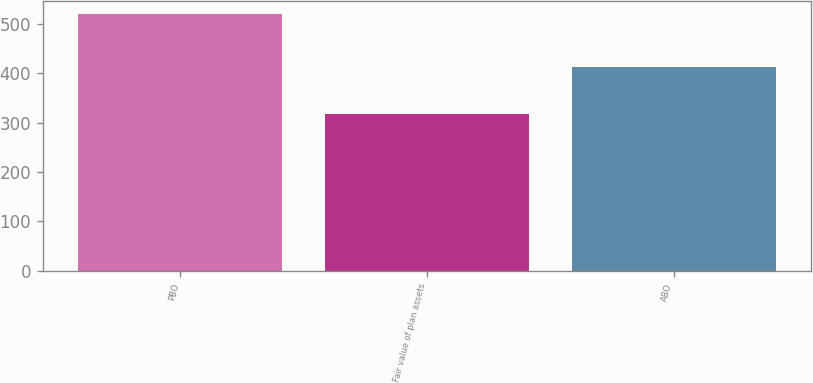Convert chart to OTSL. <chart><loc_0><loc_0><loc_500><loc_500><bar_chart><fcel>PBO<fcel>Fair value of plan assets<fcel>ABO<nl><fcel>521.1<fcel>318<fcel>413.3<nl></chart> 